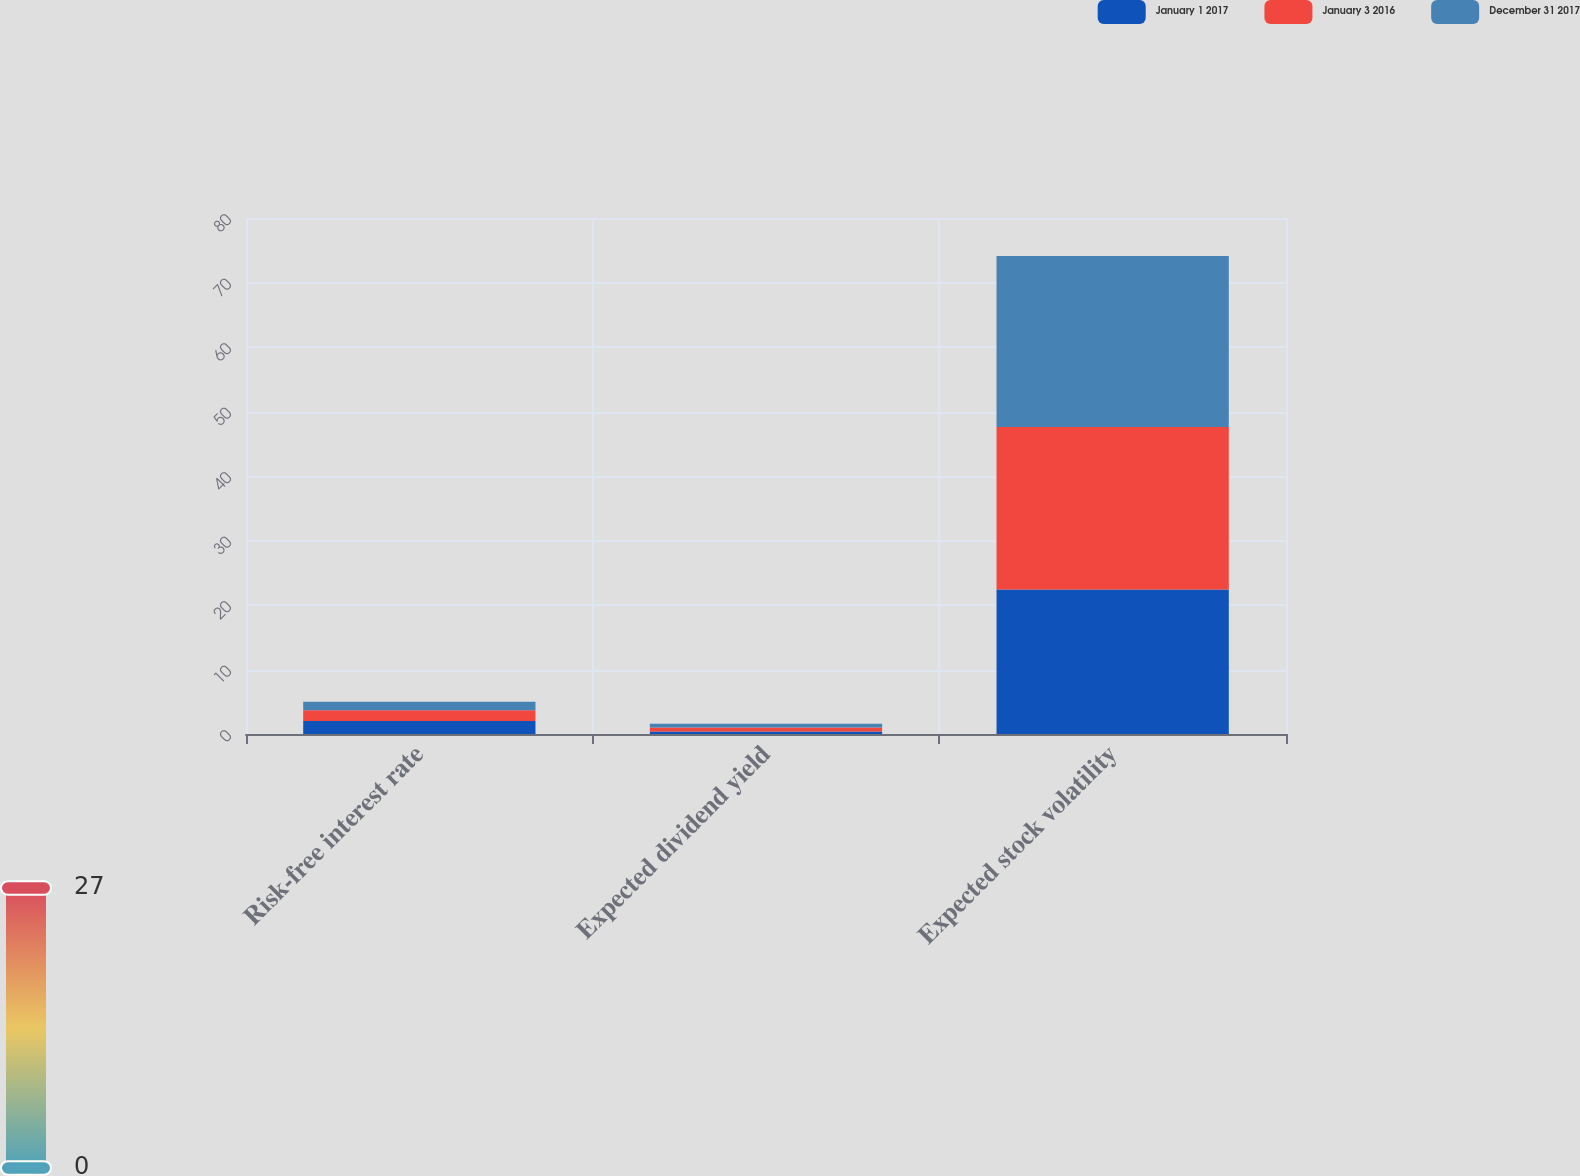<chart> <loc_0><loc_0><loc_500><loc_500><stacked_bar_chart><ecel><fcel>Risk-free interest rate<fcel>Expected dividend yield<fcel>Expected stock volatility<nl><fcel>January 1 2017<fcel>2<fcel>0.4<fcel>22.4<nl><fcel>January 3 2016<fcel>1.7<fcel>0.6<fcel>25.2<nl><fcel>December 31 2017<fcel>1.3<fcel>0.6<fcel>26.5<nl></chart> 